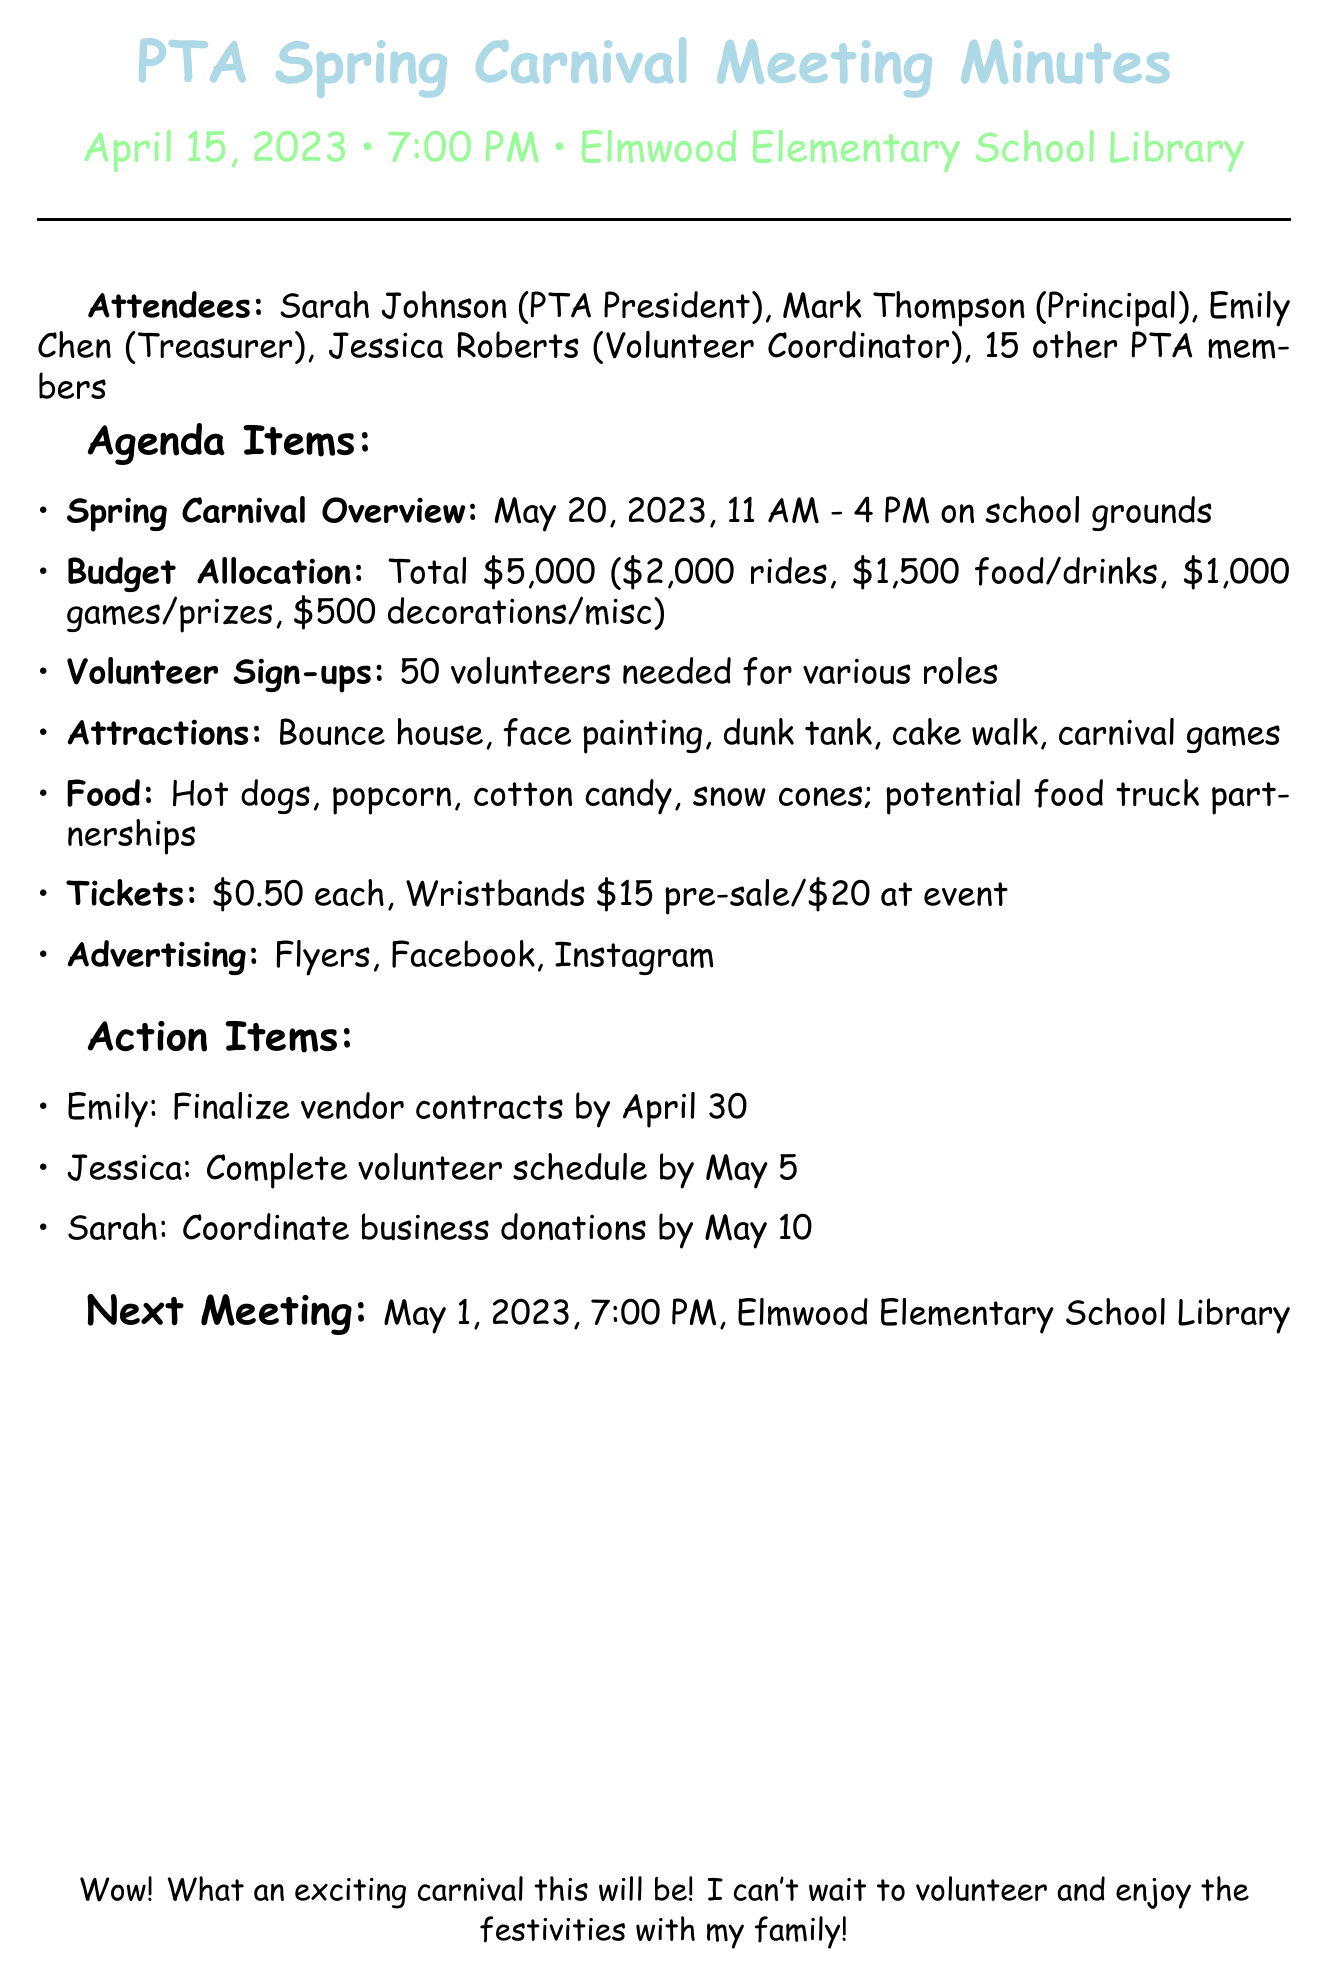What is the date of the spring carnival? The spring carnival is set for May 20, 2023, as mentioned in the overview section.
Answer: May 20, 2023 What is the total budget for the carnival? The total budget of $5,000 is outlined in the budget allocation section.
Answer: $5,000 How many volunteers are needed? The document states that 50 volunteers are required for various roles during the carnival.
Answer: 50 What type of food will be served? The food items listed include hot dogs, popcorn, cotton candy, and snow cones.
Answer: Hot dogs, popcorn, cotton candy, and snow cones Who is responsible for finalizing vendor contracts? Emily Chen is assigned the task of finalizing vendor contracts by April 30.
Answer: Emily What is the price of individual tickets? The document clearly states that individual tickets cost $0.50 each.
Answer: $0.50 When is the next PTA meeting scheduled? The next meeting is scheduled for May 1, 2023, as mentioned in the meeting details.
Answer: May 1, 2023 What attractions will be available at the carnival? Attractions mentioned include a bounce house, face painting, dunk tank, cake walk, and carnival games.
Answer: Bounce house, face painting, dunk tank, cake walk, and carnival games Who will complete the volunteer schedule? Jessica Roberts has the responsibility to complete the volunteer schedule by May 5.
Answer: Jessica 